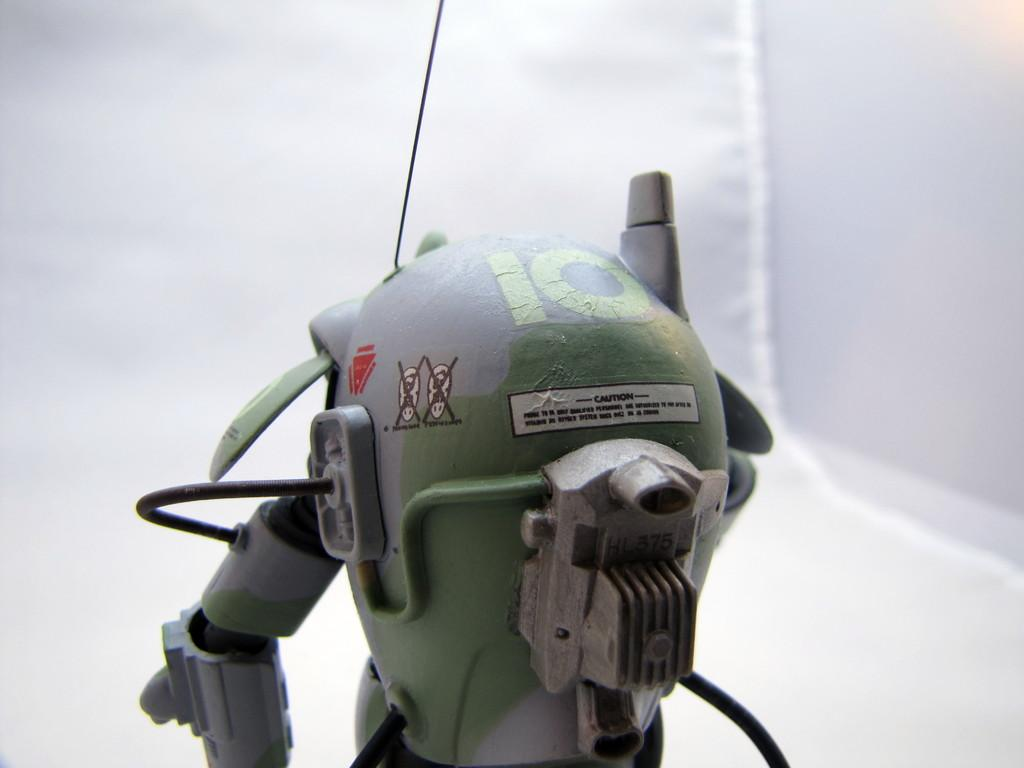What is the main subject in the middle of the image? There is a robot in the middle of the image. What color is the background of the image? The background of the image is white. What can be seen on the robot itself? There is text on the robot. What advice does the robot's mother give to the robot in the image? There is no mention of a robot's mother in the image, and therefore no advice can be observed. 